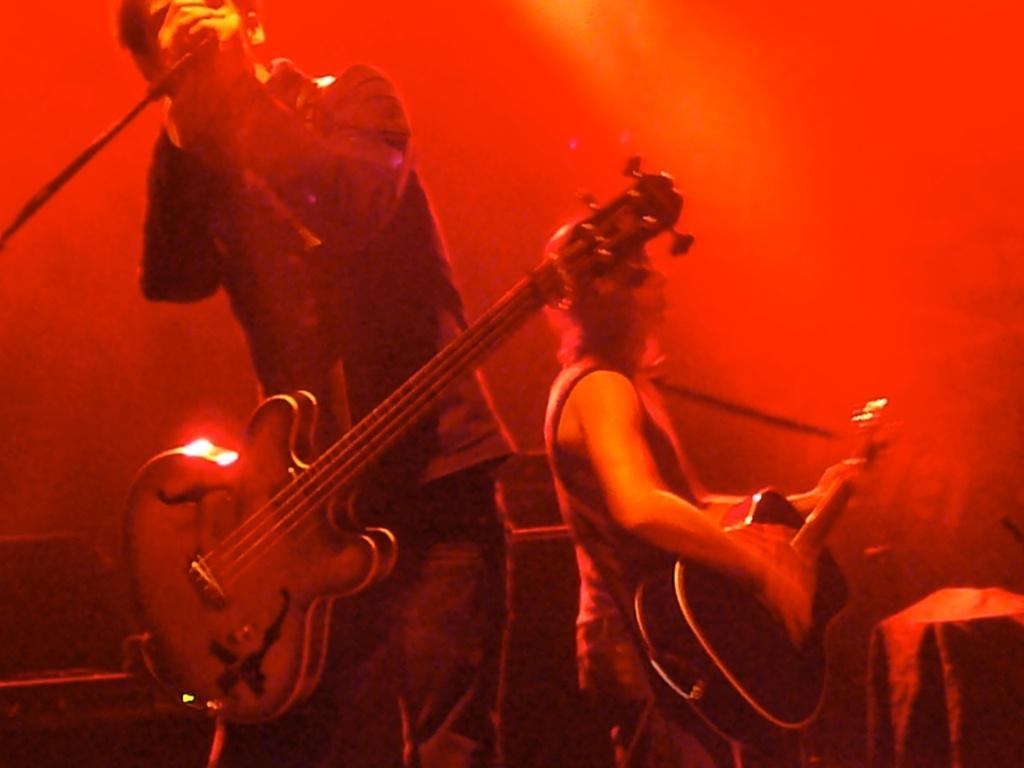Describe this image in one or two sentences. A man is standing in the left side and singing in the microphone and also he wear a guitar. 